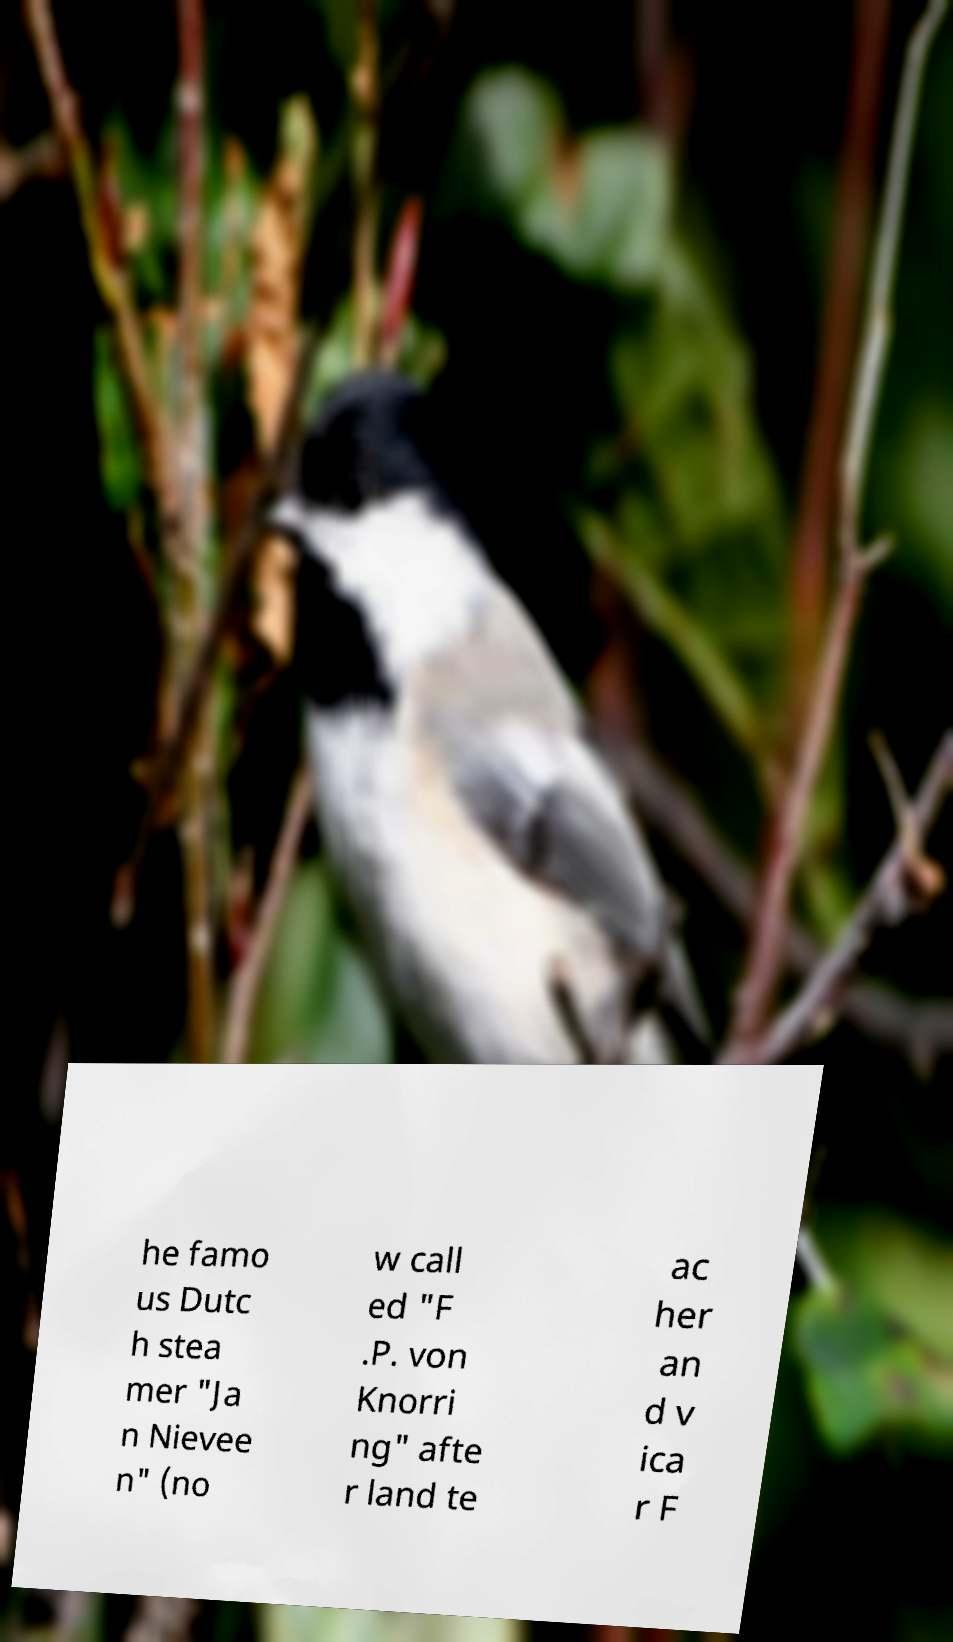What messages or text are displayed in this image? I need them in a readable, typed format. he famo us Dutc h stea mer "Ja n Nievee n" (no w call ed "F .P. von Knorri ng" afte r land te ac her an d v ica r F 